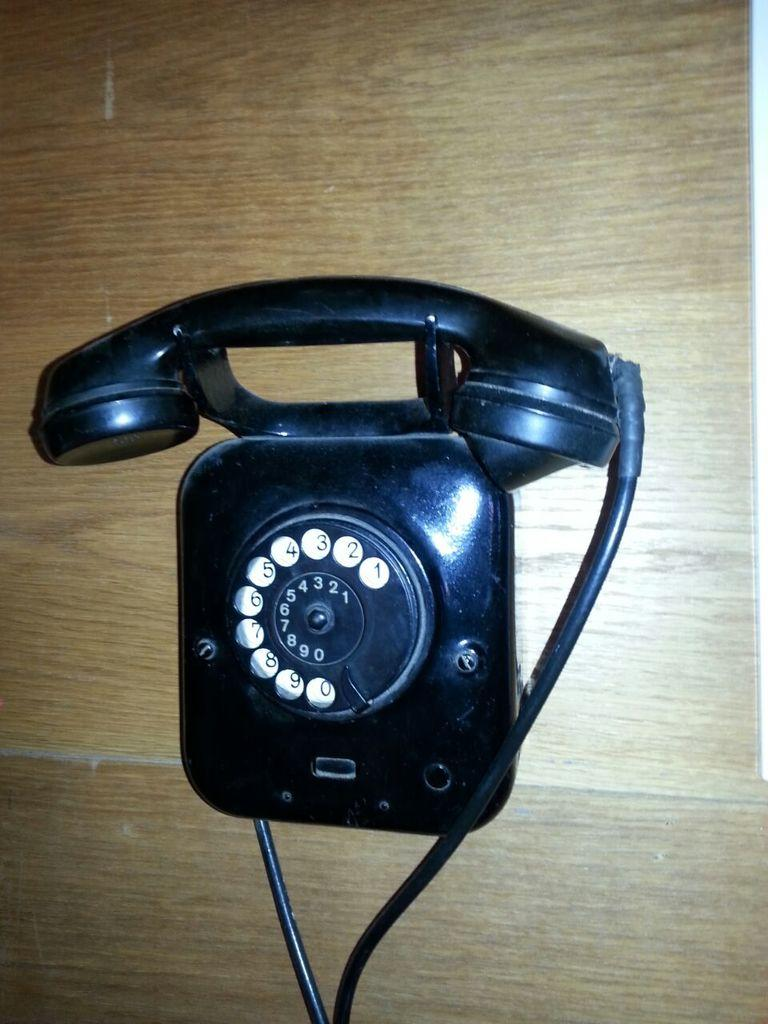What type of telephone is visible in the image? There is a landline telephone in the image. What is the landline telephone placed on? The landline telephone is on a wooden platform. What type of soup is being prepared on the wooden platform in the image? There is no soup or any indication of cooking or food preparation in the image; it only features a landline telephone on a wooden platform. 